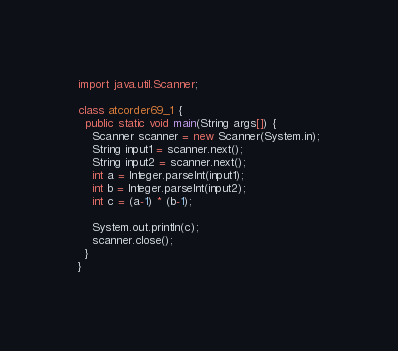Convert code to text. <code><loc_0><loc_0><loc_500><loc_500><_Java_>import java.util.Scanner;

class atcorder69_1 {
  public static void main(String args[]) {
    Scanner scanner = new Scanner(System.in);
    String input1 = scanner.next();
    String input2 = scanner.next();
    int a = Integer.parseInt(input1);
    int b = Integer.parseInt(input2);
    int c = (a-1) * (b-1);

    System.out.println(c);
    scanner.close();
  }
}</code> 